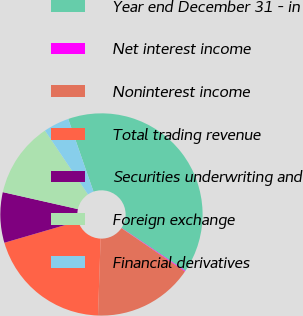<chart> <loc_0><loc_0><loc_500><loc_500><pie_chart><fcel>Year end December 31 - in<fcel>Net interest income<fcel>Noninterest income<fcel>Total trading revenue<fcel>Securities underwriting and<fcel>Foreign exchange<fcel>Financial derivatives<nl><fcel>39.75%<fcel>0.14%<fcel>15.98%<fcel>19.94%<fcel>8.06%<fcel>12.02%<fcel>4.1%<nl></chart> 